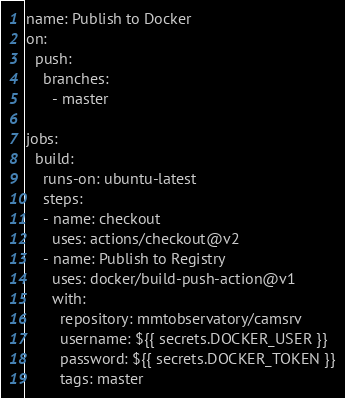Convert code to text. <code><loc_0><loc_0><loc_500><loc_500><_YAML_>name: Publish to Docker
on:
  push:
    branches:
      - master

jobs:
  build:
    runs-on: ubuntu-latest
    steps:
    - name: checkout
      uses: actions/checkout@v2
    - name: Publish to Registry
      uses: docker/build-push-action@v1
      with:
        repository: mmtobservatory/camsrv
        username: ${{ secrets.DOCKER_USER }}
        password: ${{ secrets.DOCKER_TOKEN }}
        tags: master
</code> 